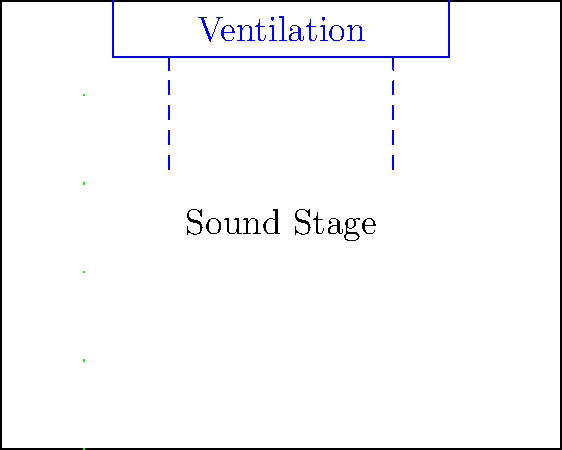As a movie star involved in production, you're consulting on a new sound stage design. The engineers want to minimize noise from the ventilation system while ensuring proper airflow. Given that the sound stage has dimensions of 30m x 24m x 10m, and the ventilation system needs to provide an air change rate of 6 ACH (air changes per hour), what should be the maximum air velocity through the ventilation ducts to keep the noise level below 30 dB? To solve this problem, we'll follow these steps:

1. Calculate the volume of the sound stage:
   $V = 30m \times 24m \times 10m = 7200 m^3$

2. Calculate the required airflow rate:
   Airflow rate $= V \times ACH = 7200 m^3 \times 6 h^{-1} = 43200 m^3/h$
   Convert to $m^3/s$: $43200 m^3/h \div 3600 s/h = 12 m^3/s$

3. Use the empirical relationship between air velocity and noise level:
   $L_p = 50 \log_{10}(v) + 10 \log_{10}(A) + K$
   Where:
   $L_p$ is the sound pressure level (dB)
   $v$ is the air velocity (m/s)
   $A$ is the duct cross-sectional area (m²)
   $K$ is a constant (assume $K = 7$ for this calculation)

4. Rearrange the equation to solve for $v$:
   $30 = 50 \log_{10}(v) + 10 \log_{10}(A) + 7$
   $23 = 50 \log_{10}(v) + 10 \log_{10}(A)$
   $\frac{23 - 10 \log_{10}(A)}{50} = \log_{10}(v)$
   $v = 10^{\frac{23 - 10 \log_{10}(A)}{50}}$

5. Assume a reasonable duct size, e.g., 1m x 1m ($A = 1 m^2$):
   $v = 10^{\frac{23 - 10 \log_{10}(1)}{50}} \approx 3.98 m/s$

6. Check if this velocity can provide the required airflow:
   $Q = v \times A = 3.98 m/s \times 1 m^2 = 3.98 m^3/s$
   This is less than the required $12 m^3/s$, so we need a larger duct.

7. Try a 2m x 2m duct ($A = 4 m^2$):
   $v = 10^{\frac{23 - 10 \log_{10}(4)}{50}} \approx 3.16 m/s$
   $Q = 3.16 m/s \times 4 m^2 = 12.64 m^3/s$

This satisfies the airflow requirement and keeps the noise level below 30 dB.
Answer: 3.16 m/s through a 2m x 2m duct 